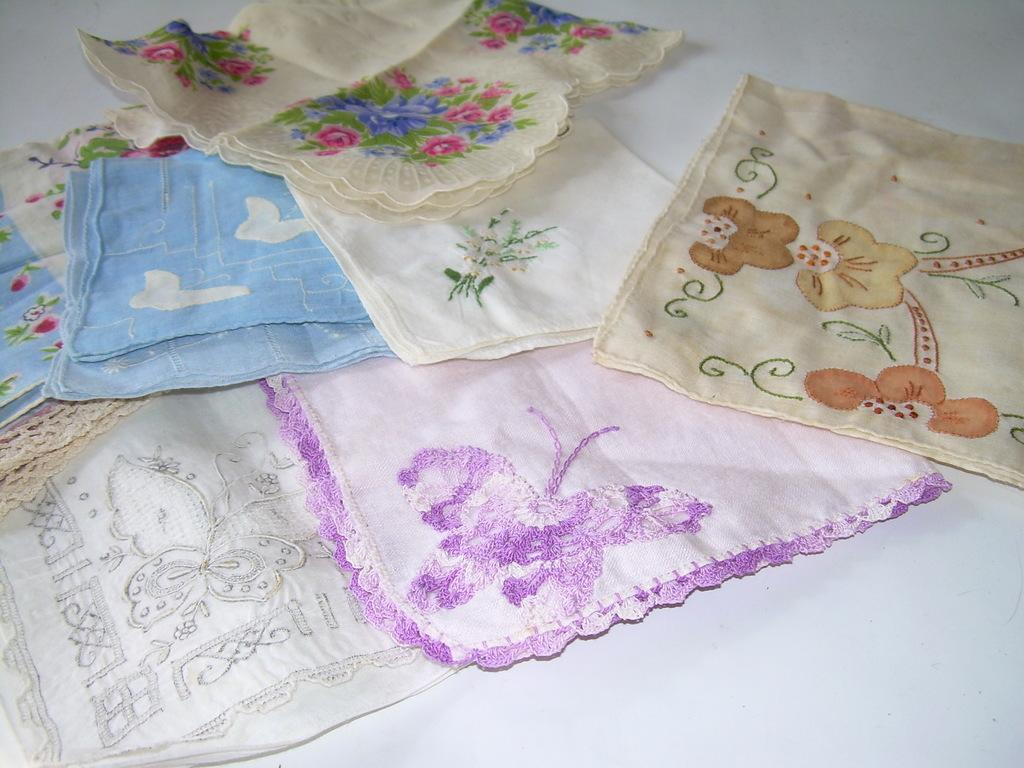What type of items are present in the image that are used for cleaning or wiping or wiping? There are handkerchiefs or napkins in the image. What colors are the handkerchiefs or napkins? The handkerchiefs or napkins are in white, blue, and violet colors. What can be seen in the image besides the handkerchiefs or napkins? There is a design in the image. What colors are used in the design? A: The design is in blue, brown, and pink colors. What is the background color of the image? The background of the image is white. Can you see a gun in the image? No, there is no gun present in the image. 